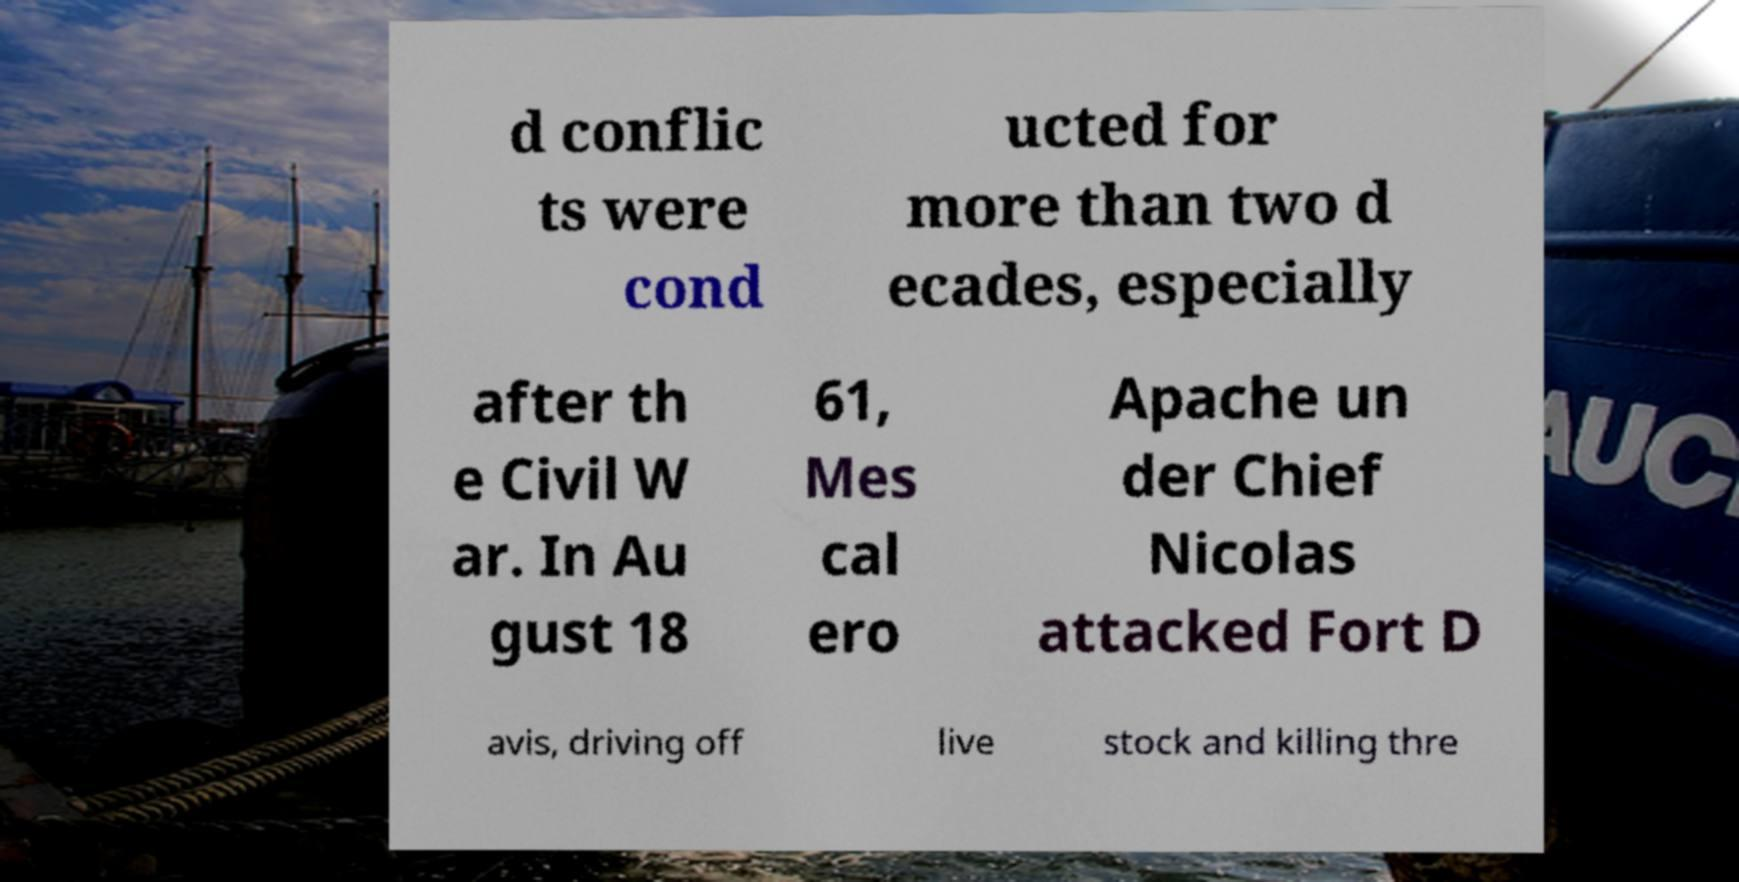Can you accurately transcribe the text from the provided image for me? d conflic ts were cond ucted for more than two d ecades, especially after th e Civil W ar. In Au gust 18 61, Mes cal ero Apache un der Chief Nicolas attacked Fort D avis, driving off live stock and killing thre 